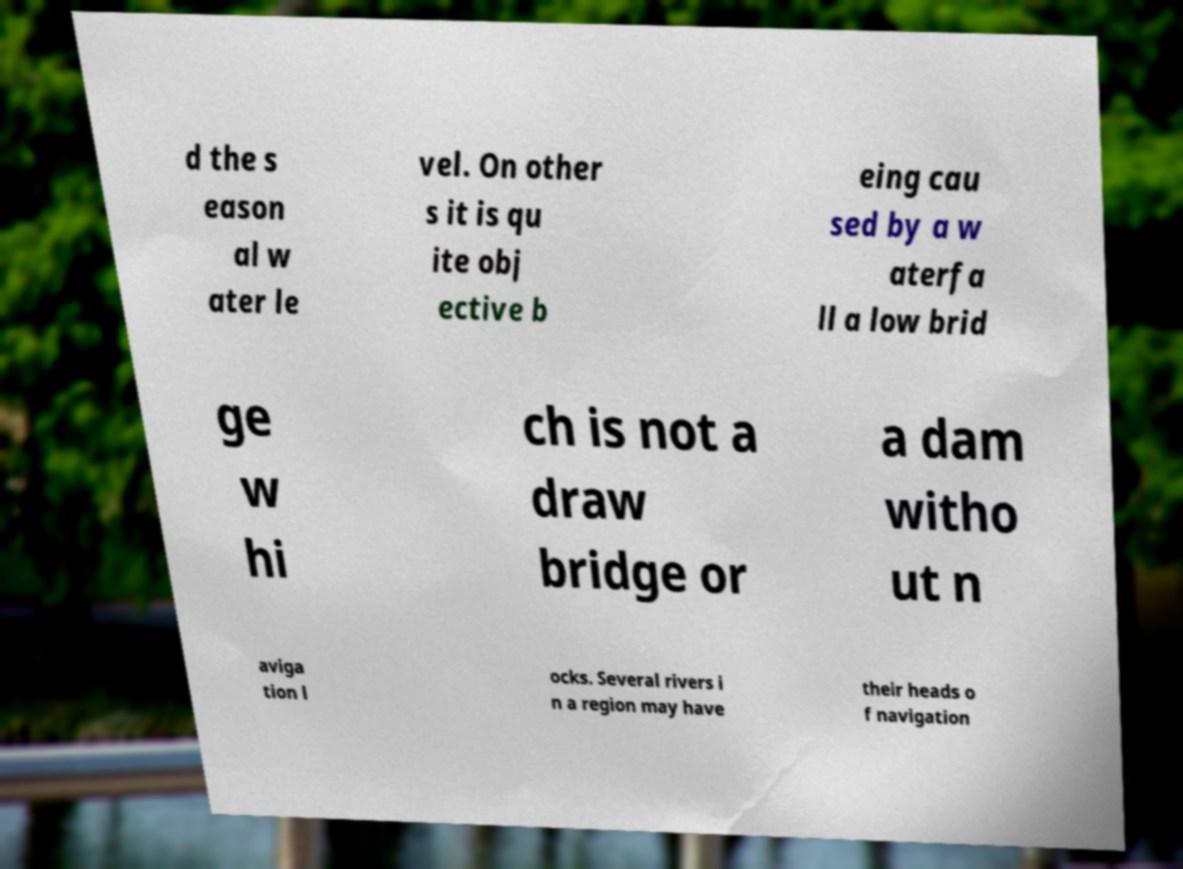I need the written content from this picture converted into text. Can you do that? d the s eason al w ater le vel. On other s it is qu ite obj ective b eing cau sed by a w aterfa ll a low brid ge w hi ch is not a draw bridge or a dam witho ut n aviga tion l ocks. Several rivers i n a region may have their heads o f navigation 